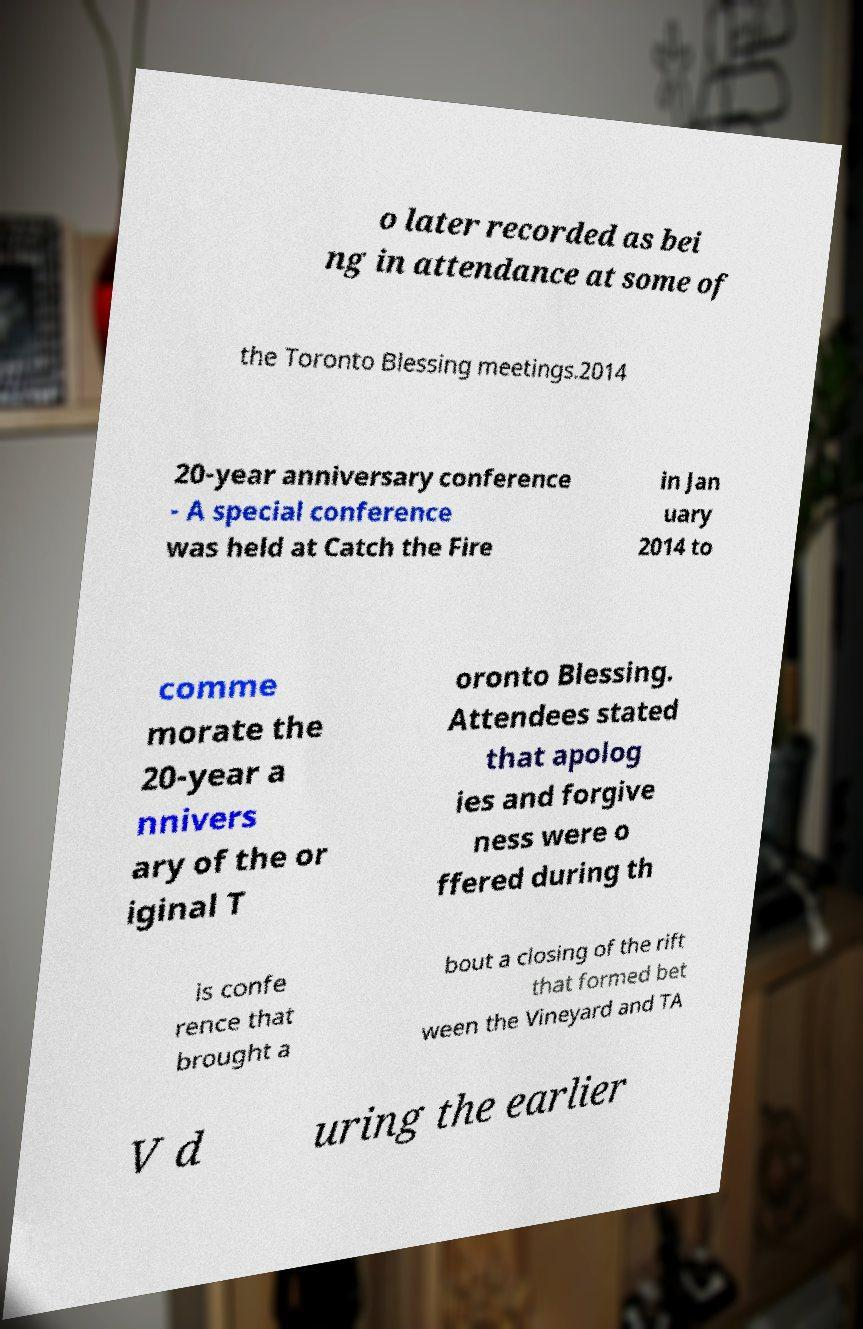Could you extract and type out the text from this image? o later recorded as bei ng in attendance at some of the Toronto Blessing meetings.2014 20-year anniversary conference - A special conference was held at Catch the Fire in Jan uary 2014 to comme morate the 20-year a nnivers ary of the or iginal T oronto Blessing. Attendees stated that apolog ies and forgive ness were o ffered during th is confe rence that brought a bout a closing of the rift that formed bet ween the Vineyard and TA V d uring the earlier 